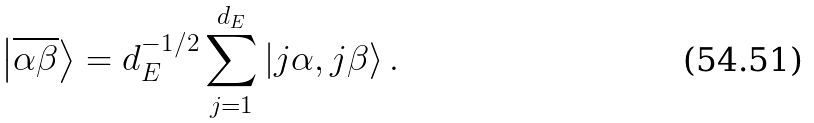<formula> <loc_0><loc_0><loc_500><loc_500>\left | \overline { \alpha \beta } \right \rangle = d _ { E } ^ { - 1 / 2 } \sum _ { j = 1 } ^ { d _ { E } } \left | { j \alpha , j \beta } \right \rangle .</formula> 